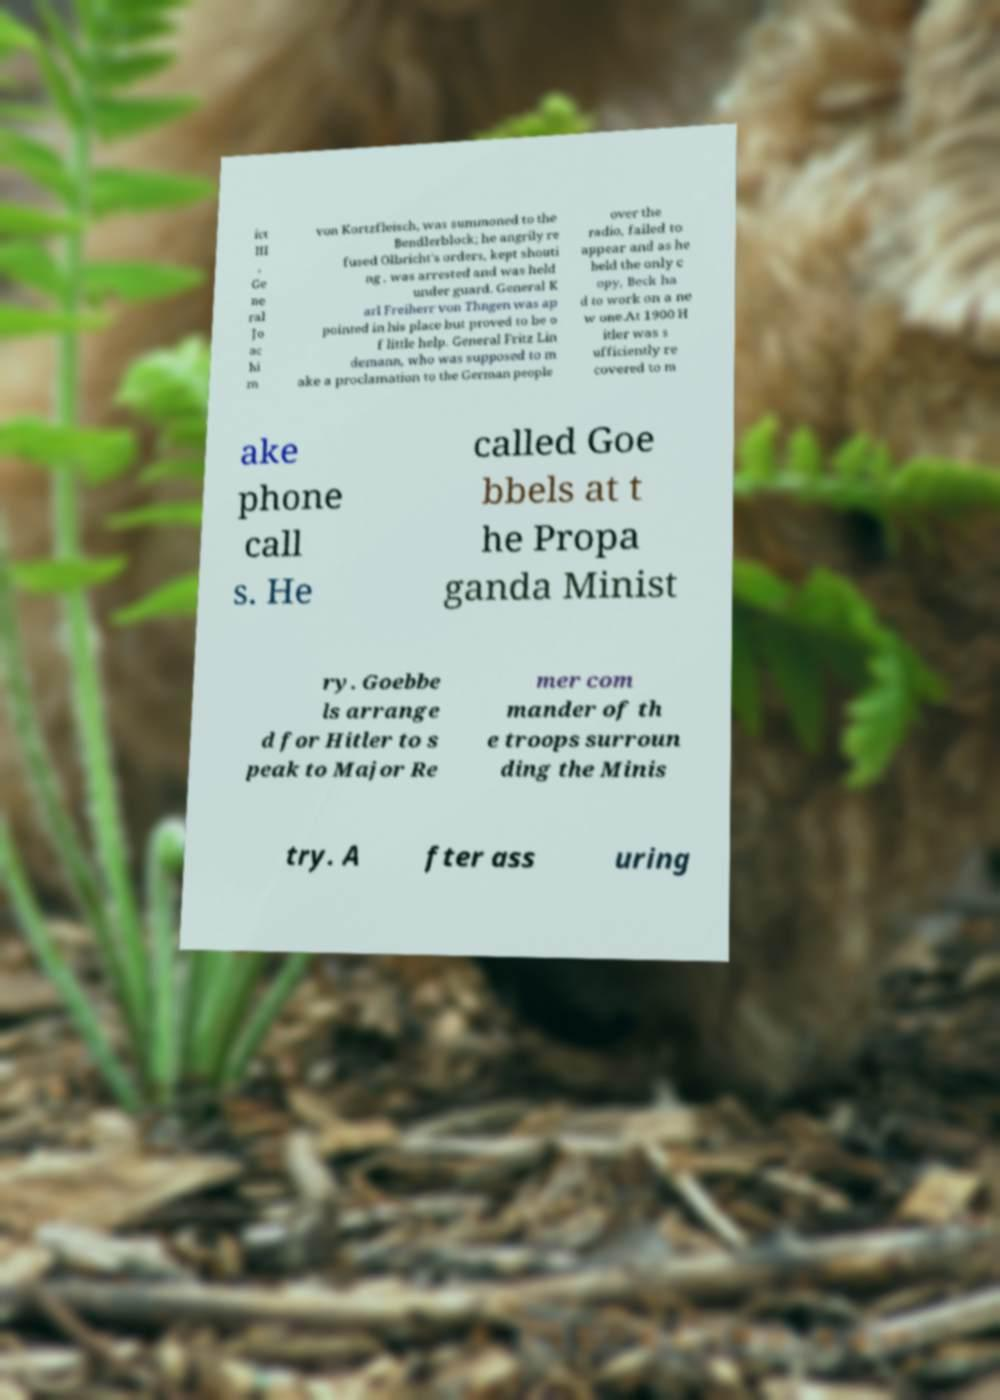Can you read and provide the text displayed in the image?This photo seems to have some interesting text. Can you extract and type it out for me? ict III , Ge ne ral Jo ac hi m von Kortzfleisch, was summoned to the Bendlerblock; he angrily re fused Olbricht's orders, kept shouti ng , was arrested and was held under guard. General K arl Freiherr von Thngen was ap pointed in his place but proved to be o f little help. General Fritz Lin demann, who was supposed to m ake a proclamation to the German people over the radio, failed to appear and as he held the only c opy, Beck ha d to work on a ne w one.At 1900 H itler was s ufficiently re covered to m ake phone call s. He called Goe bbels at t he Propa ganda Minist ry. Goebbe ls arrange d for Hitler to s peak to Major Re mer com mander of th e troops surroun ding the Minis try. A fter ass uring 